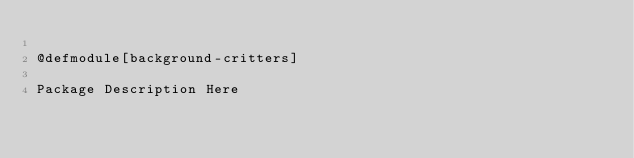<code> <loc_0><loc_0><loc_500><loc_500><_Racket_>
@defmodule[background-critters]

Package Description Here
</code> 